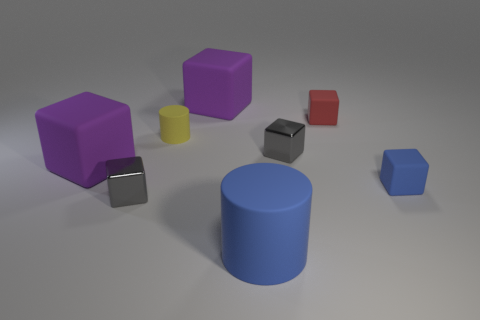The rubber block that is the same color as the large rubber cylinder is what size? The rubber block sharing the same color as the large blue cylindrical rubber has a small size. 